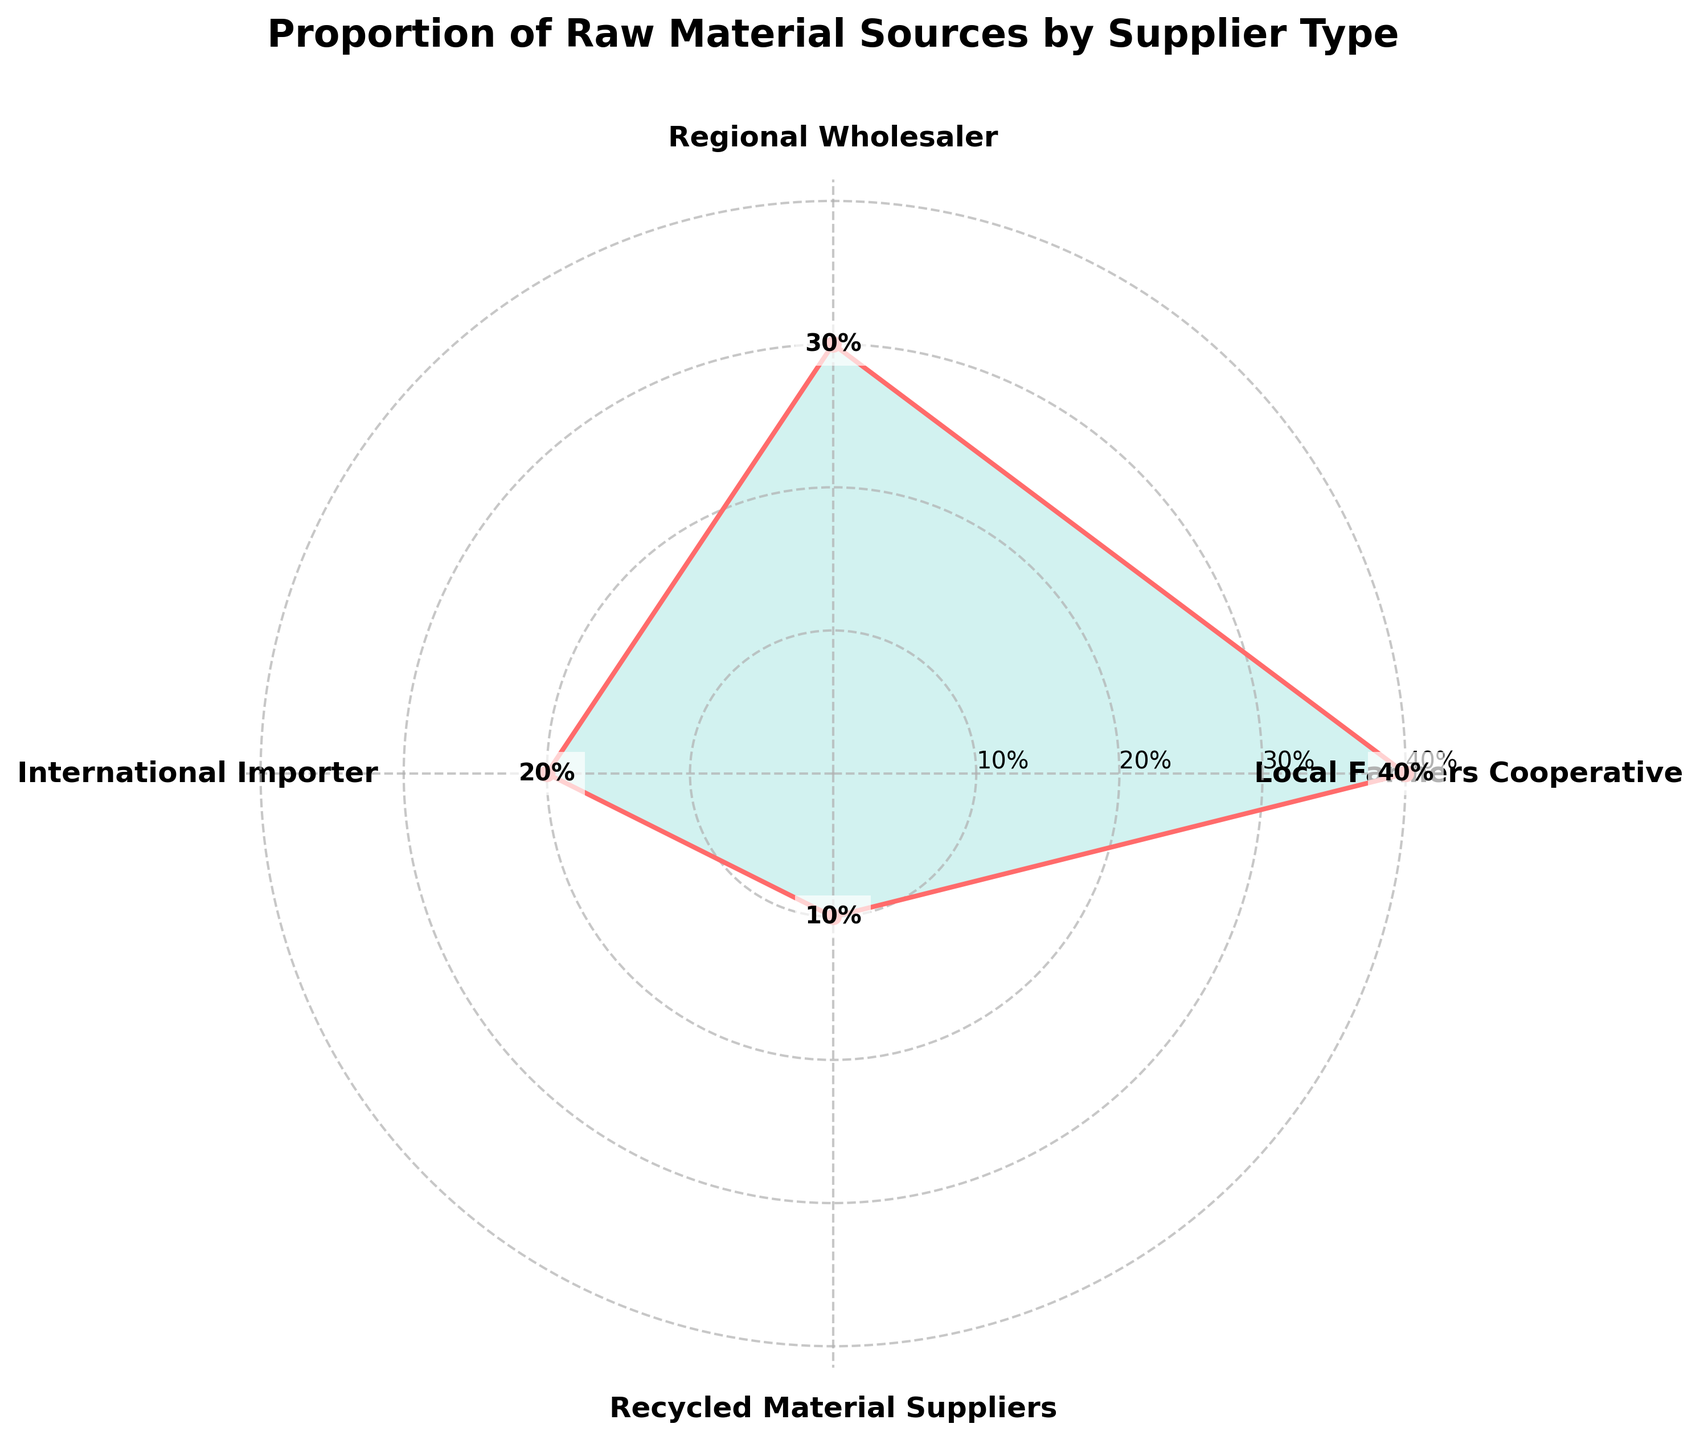What is the title of the plot? The title of the plot is usually displayed at the top of the chart. In this case, it is "Proportion of Raw Material Sources by Supplier Type"
Answer: Proportion of Raw Material Sources by Supplier Type Which supplier type has the highest proportion? By looking at the radial extensions of the plot, the longest line represents the highest proportion, which in this case is "Local Farmers Cooperative" with 40%.
Answer: Local Farmers Cooperative What is the proportion of raw material sourced from Recycled Material Suppliers? From the chart, the sector labeled "Recycled Material Suppliers" shows the value at the end of its radial line, which is 10%.
Answer: 10% What is the combined proportion of raw materials from Local Farmers Cooperative and Regional Wholesaler? First, identify the proportions for Local Farmers Cooperative (40%) and Regional Wholesaler (30%). Adding these values gives 40% + 30% = 70%.
Answer: 70% Which supplier type contributes the least to the raw material sources? The shortest radial line on the plot represents the smallest proportion, which is "Recycled Material Suppliers" with 10%.
Answer: Recycled Material Suppliers How many supplier types are represented in the chart? Count the number of different labels around the chart. There are four supplier types: Local Farmers Cooperative, Regional Wholesaler, International Importer, and Recycled Material Suppliers.
Answer: Four Is the proportion of International Importer greater than that of Recycled Material Suppliers? Compare the lengths of the radial lines for "International Importer" and "Recycled Material Suppliers". The proportion for International Importer (20%) is greater than that for Recycled Material Suppliers (10%).
Answer: Yes How much larger is the proportion of Regional Wholesaler compared to International Importer? Subtract the proportion of International Importer (20%) from the proportion of Regional Wholesaler (30%). The difference is 30% - 20% = 10%.
Answer: 10% What is the median proportion value among the supplier types? Arrange the proportions in ascending order: 10%, 20%, 30%, and 40%. With four values, the median is the average of the two middle values: (20% + 30%) / 2 = 25%.
Answer: 25% What is the average proportion of the raw material sources from all supplier types? Add all the proportions: 40% + 30% + 20% + 10% = 100%. Divide by the number of supplier types (4). The average is 100% / 4 = 25%.
Answer: 25% 